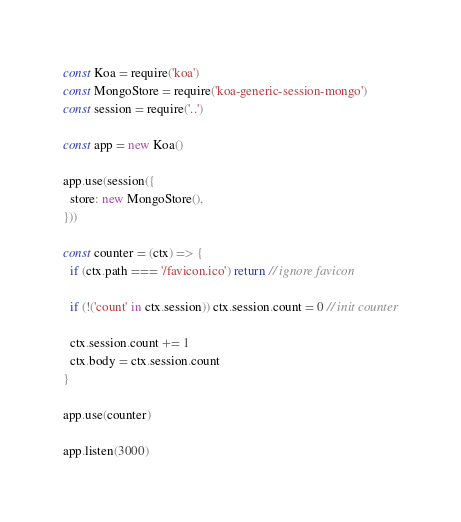<code> <loc_0><loc_0><loc_500><loc_500><_JavaScript_>const Koa = require('koa')
const MongoStore = require('koa-generic-session-mongo')
const session = require('..')

const app = new Koa()

app.use(session({
  store: new MongoStore(),
}))

const counter = (ctx) => {
  if (ctx.path === '/favicon.ico') return // ignore favicon

  if (!('count' in ctx.session)) ctx.session.count = 0 // init counter

  ctx.session.count += 1
  ctx.body = ctx.session.count
}

app.use(counter)

app.listen(3000)
</code> 